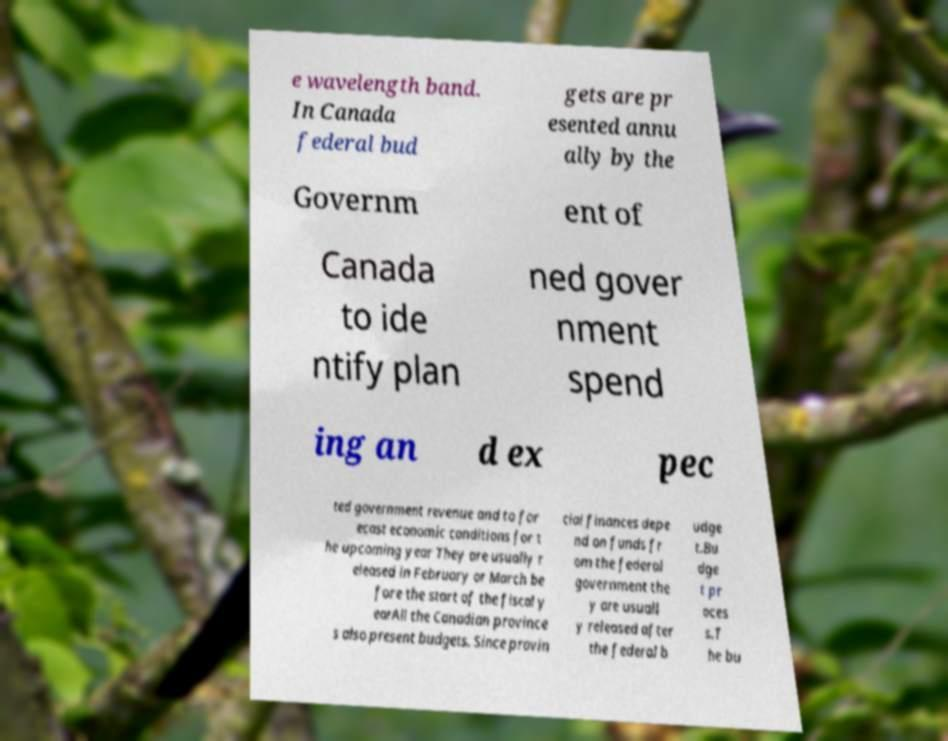Please identify and transcribe the text found in this image. e wavelength band. In Canada federal bud gets are pr esented annu ally by the Governm ent of Canada to ide ntify plan ned gover nment spend ing an d ex pec ted government revenue and to for ecast economic conditions for t he upcoming year They are usually r eleased in February or March be fore the start of the fiscal y earAll the Canadian province s also present budgets. Since provin cial finances depe nd on funds fr om the federal government the y are usuall y released after the federal b udge t.Bu dge t pr oces s.T he bu 